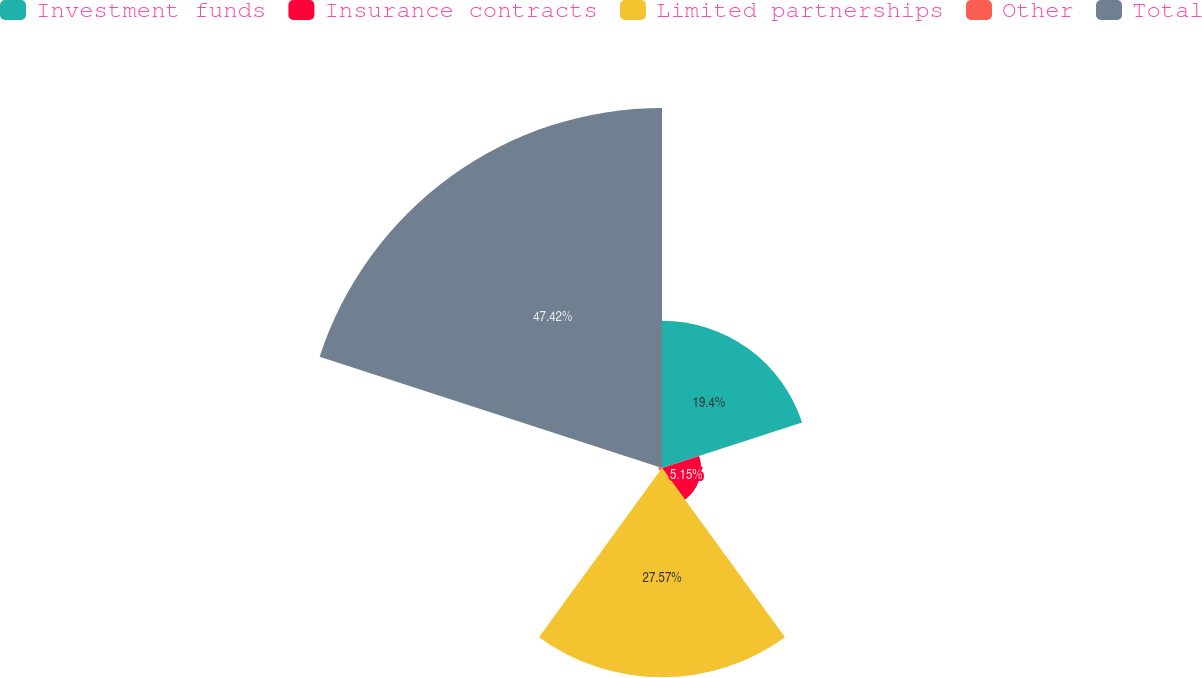<chart> <loc_0><loc_0><loc_500><loc_500><pie_chart><fcel>Investment funds<fcel>Insurance contracts<fcel>Limited partnerships<fcel>Other<fcel>Total<nl><fcel>19.4%<fcel>5.15%<fcel>27.57%<fcel>0.46%<fcel>47.42%<nl></chart> 